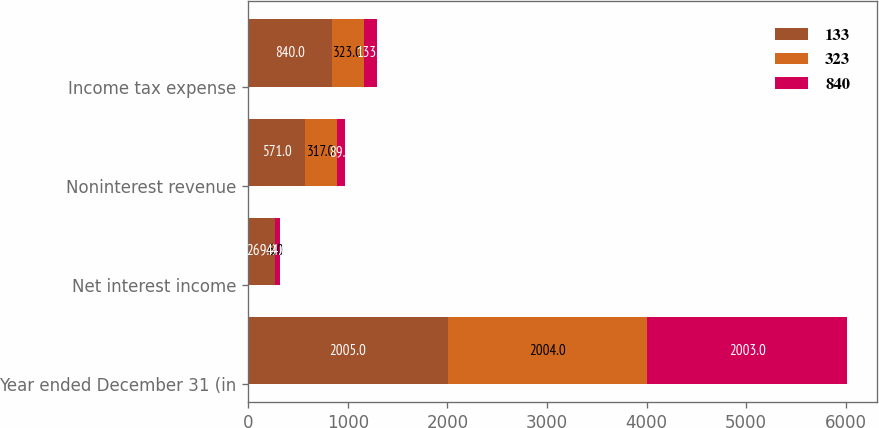Convert chart. <chart><loc_0><loc_0><loc_500><loc_500><stacked_bar_chart><ecel><fcel>Year ended December 31 (in<fcel>Net interest income<fcel>Noninterest revenue<fcel>Income tax expense<nl><fcel>133<fcel>2005<fcel>269<fcel>571<fcel>840<nl><fcel>323<fcel>2004<fcel>6<fcel>317<fcel>323<nl><fcel>840<fcel>2003<fcel>44<fcel>89<fcel>133<nl></chart> 